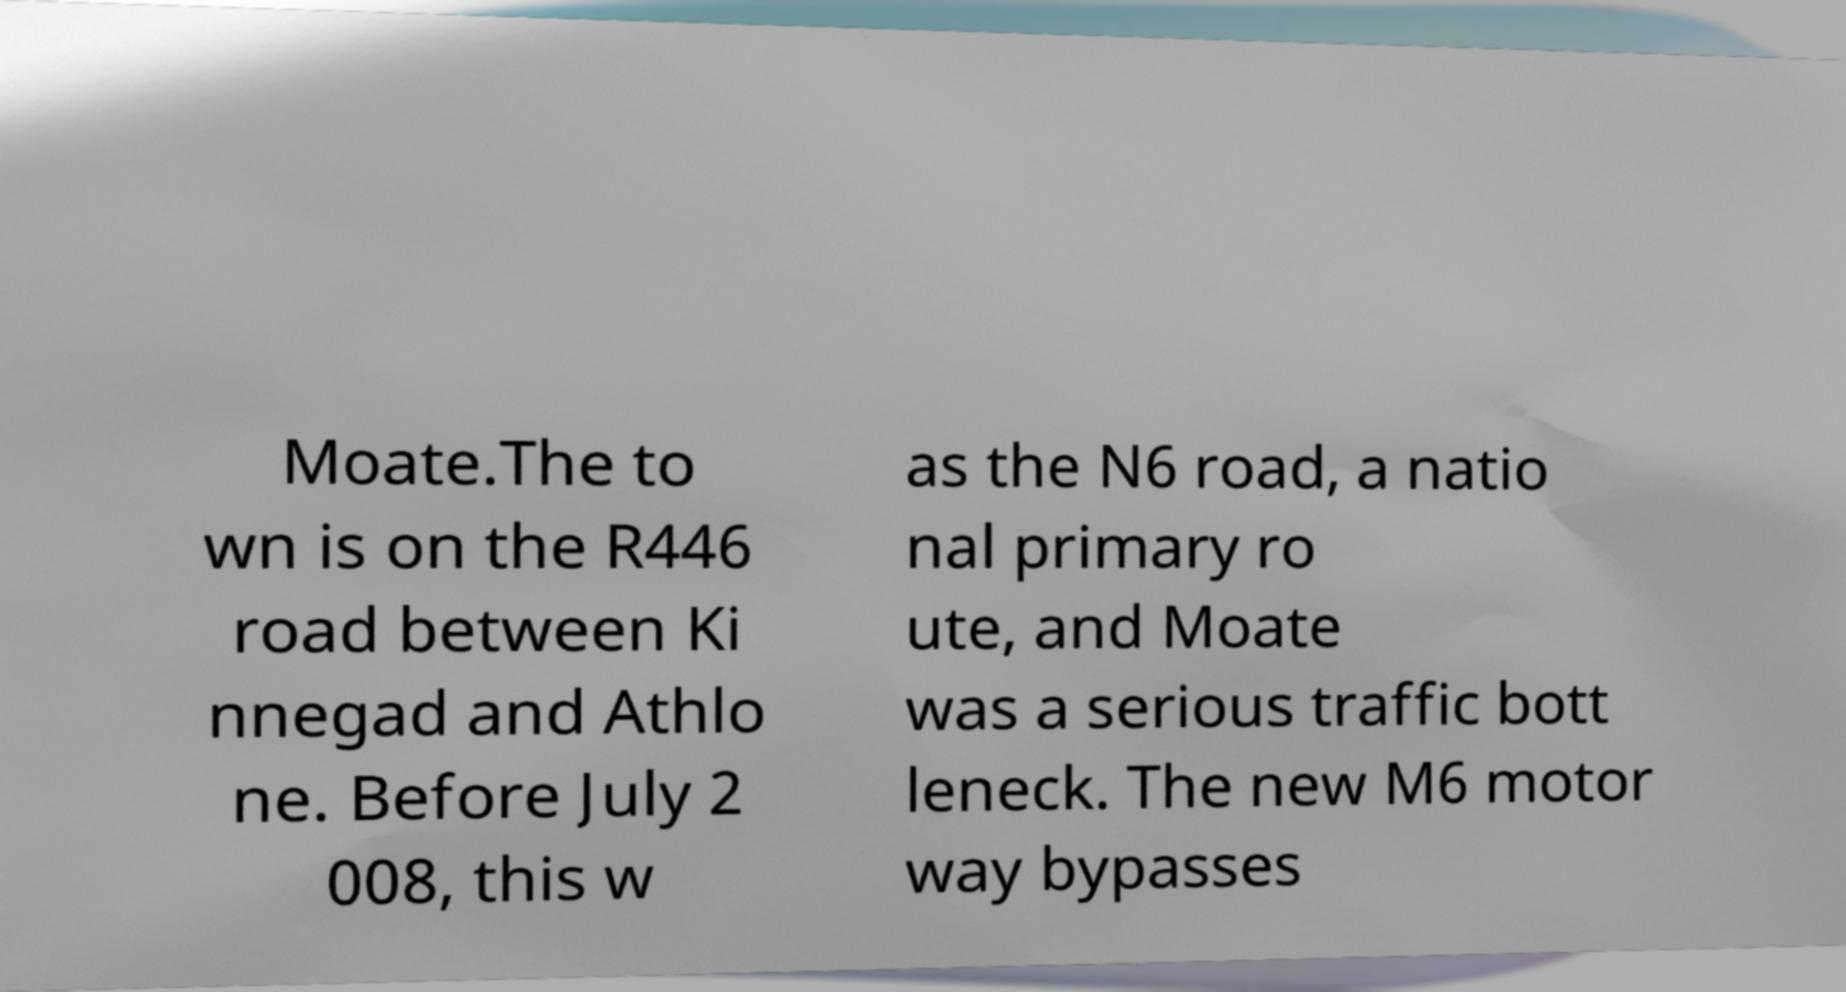What messages or text are displayed in this image? I need them in a readable, typed format. Moate.The to wn is on the R446 road between Ki nnegad and Athlo ne. Before July 2 008, this w as the N6 road, a natio nal primary ro ute, and Moate was a serious traffic bott leneck. The new M6 motor way bypasses 